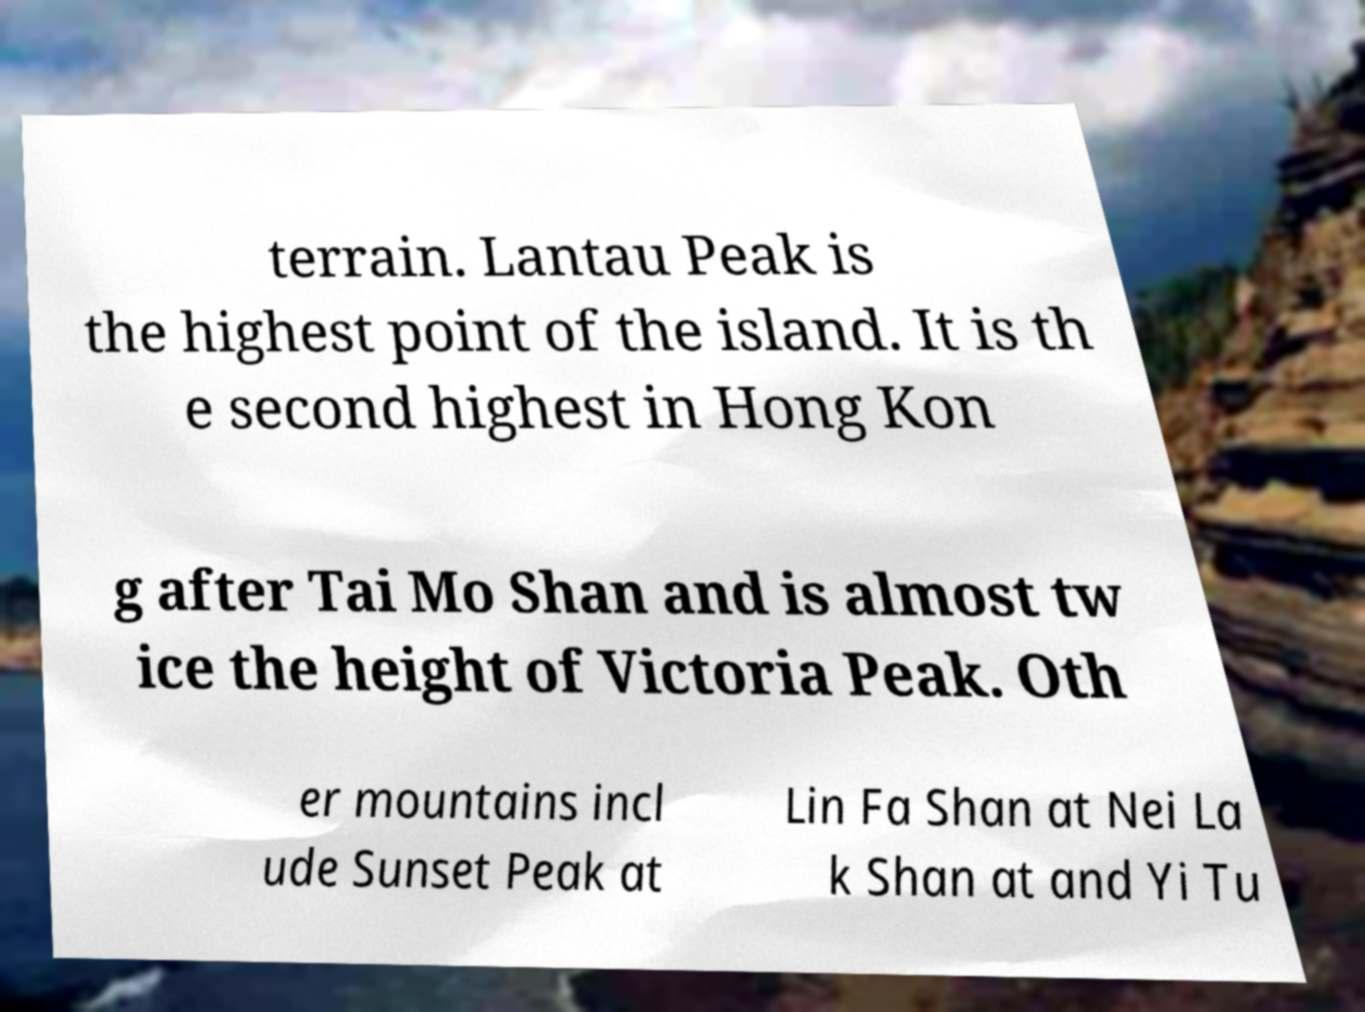For documentation purposes, I need the text within this image transcribed. Could you provide that? terrain. Lantau Peak is the highest point of the island. It is th e second highest in Hong Kon g after Tai Mo Shan and is almost tw ice the height of Victoria Peak. Oth er mountains incl ude Sunset Peak at Lin Fa Shan at Nei La k Shan at and Yi Tu 